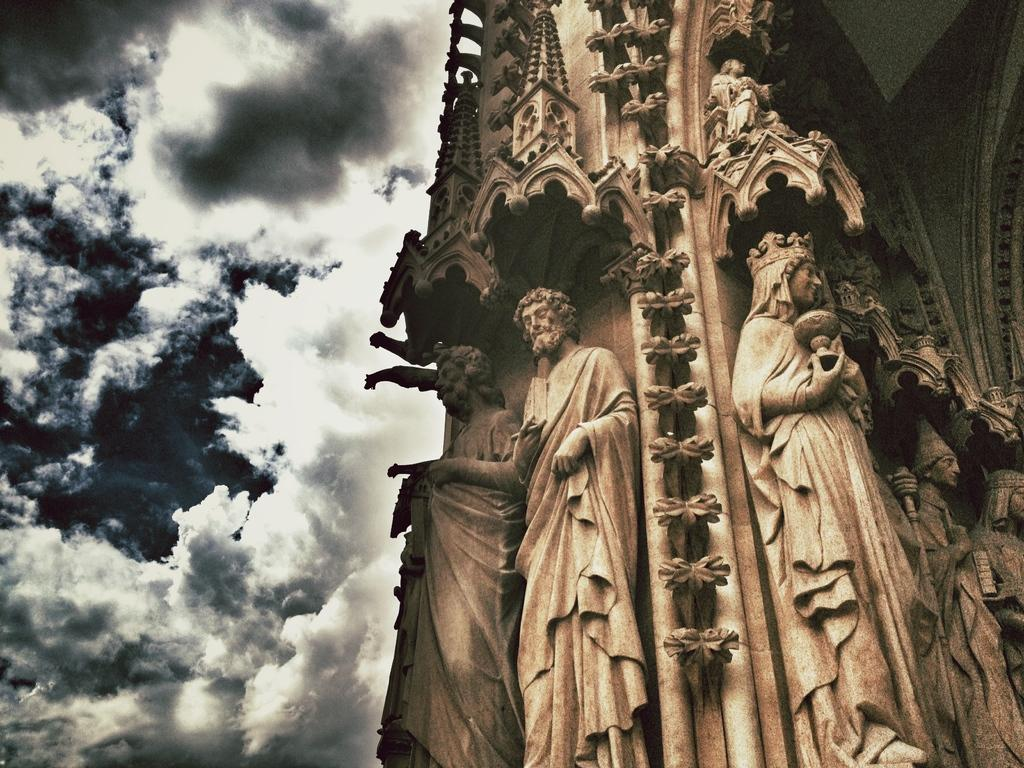What type of art is present in the image? There are sculptures in the image. What is visible in the background of the image? The sky is visible in the image. How would you describe the sky in the image? The sky appears to be cloudy. What type of cup is being used to hold the sculptures in the image? There is no cup present in the image; the sculptures are not being held by any container. 